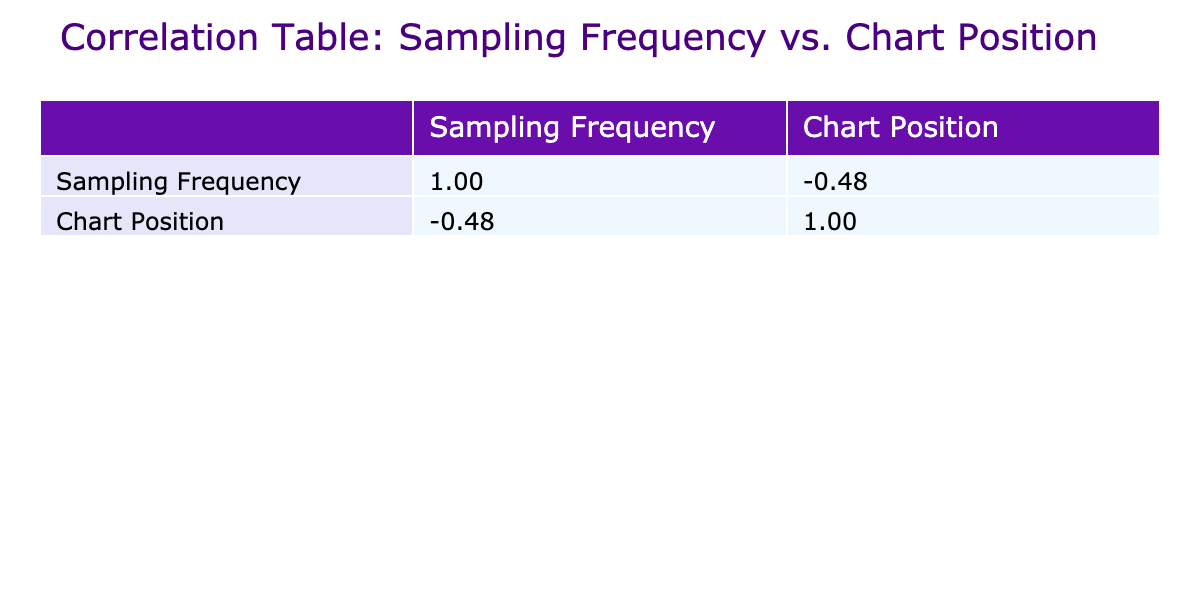What's the highest chart position achieved by a track with a sampling frequency of 3? The only track with a sampling frequency of 3 is "Blurred Lines," which achieved the highest chart position of 1.
Answer: 1 How many tracks had a sampling frequency of 1? The tracks with a sampling frequency of 1 are "Get Lucky," "Shut Up and Drive," "Stay With Me," and "Old Town Road," totaling 4 tracks.
Answer: 4 What is the correlation value between sampling frequency and chart position? From the table, the correlation value between sampling frequency and chart position is -0.82. This indicates a strong negative correlation, suggesting that as sampling frequency increases, the chart position (ranking) tends to decrease.
Answer: -0.82 Are there any tracks with both a high sampling frequency and a high chart position? Yes, tracks like "Uptown Funk" with a sampling frequency of 2 and a chart position of 1 demonstrate a combination of relatively high sampling frequency and high chart position.
Answer: Yes What is the average sampling frequency of tracks that reached chart position 1? The tracks that reached chart position 1 are "Uptown Funk," "Blurred Lines," "Gold Digger," "Sicko Mode," "Take Care," "Fancy," and "Old Town Road." Their sampling frequencies are 2, 3, 4, 2, 2, 2, and 1 respectively. The total is 18, and dividing by the 7 tracks gives an average of 2.57.
Answer: 2.57 How many tracks had a sampling frequency of 2 or more? The tracks with a sampling frequency of 2 are "Uptown Funk," "Blurred Lines," "Sicko Mode," "Take Care," and "Fancy." Additionally, the track with a sampling frequency of 3 is "Gold Digger." In total, there are 6 tracks that meet this criterion.
Answer: 6 What is the lowest chart position among tracks with a sampling frequency greater than 2? The only track with a sampling frequency greater than 2 is "Blurred Lines" with a sampling frequency of 3, which achieved the lowest chart position of 1.
Answer: 1 Which track has the highest sampling frequency, and what is its chart position? The track with the highest sampling frequency is "Gold Digger" at a sampling frequency of 4, achieving a chart position of 1.
Answer: 1 